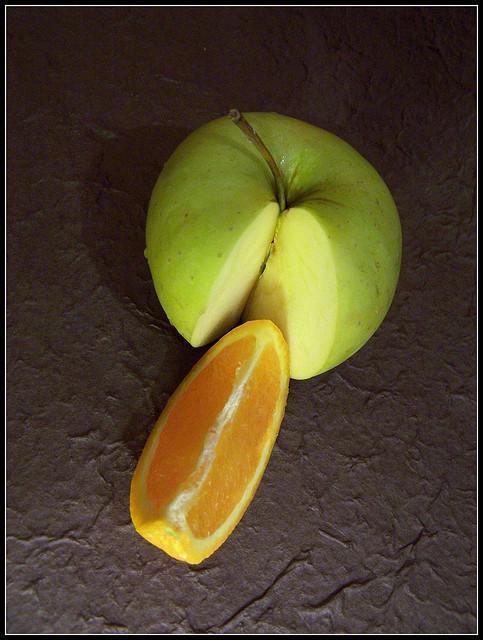How many slices of oranges it there?
Give a very brief answer. 1. How many fruits are there?
Give a very brief answer. 2. 